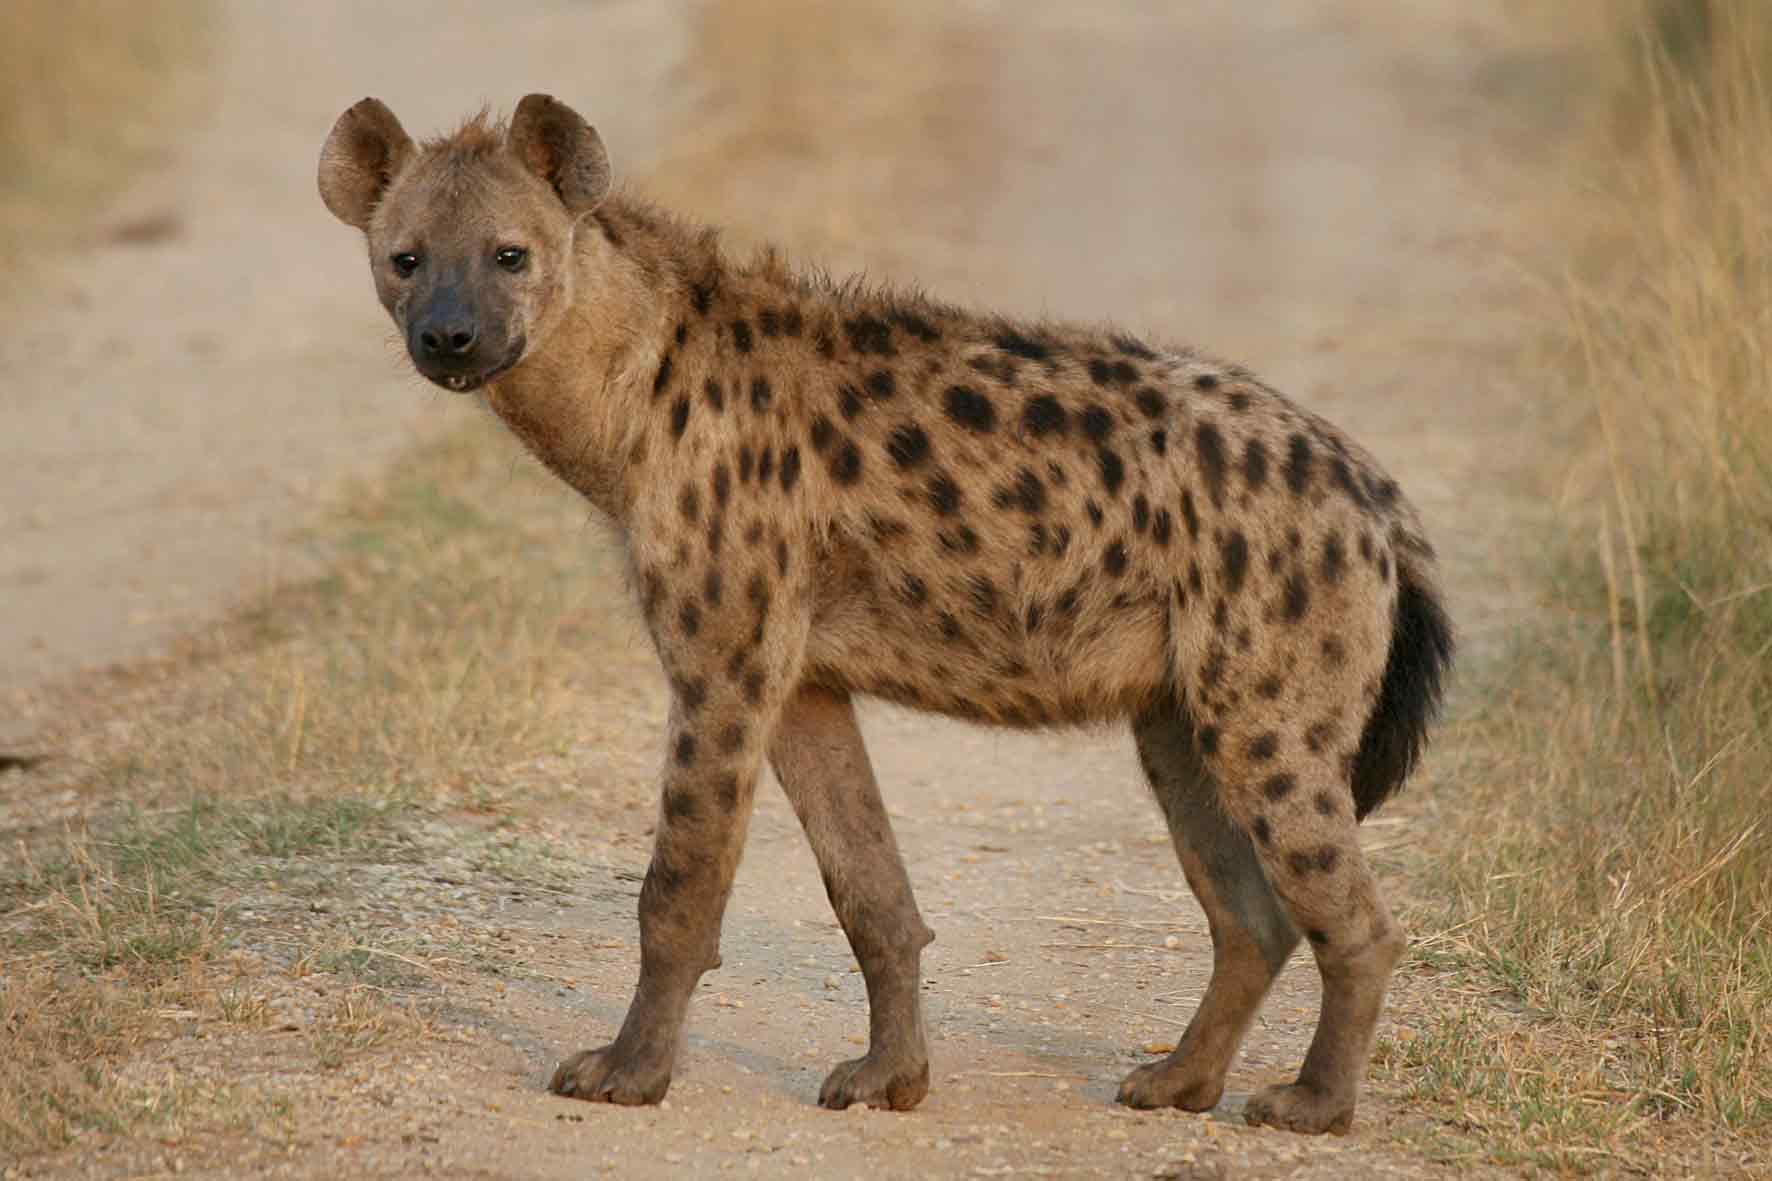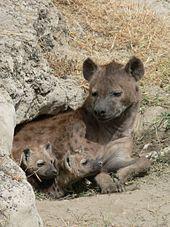The first image is the image on the left, the second image is the image on the right. For the images displayed, is the sentence "There is at least three animals total across the images." factually correct? Answer yes or no. Yes. 